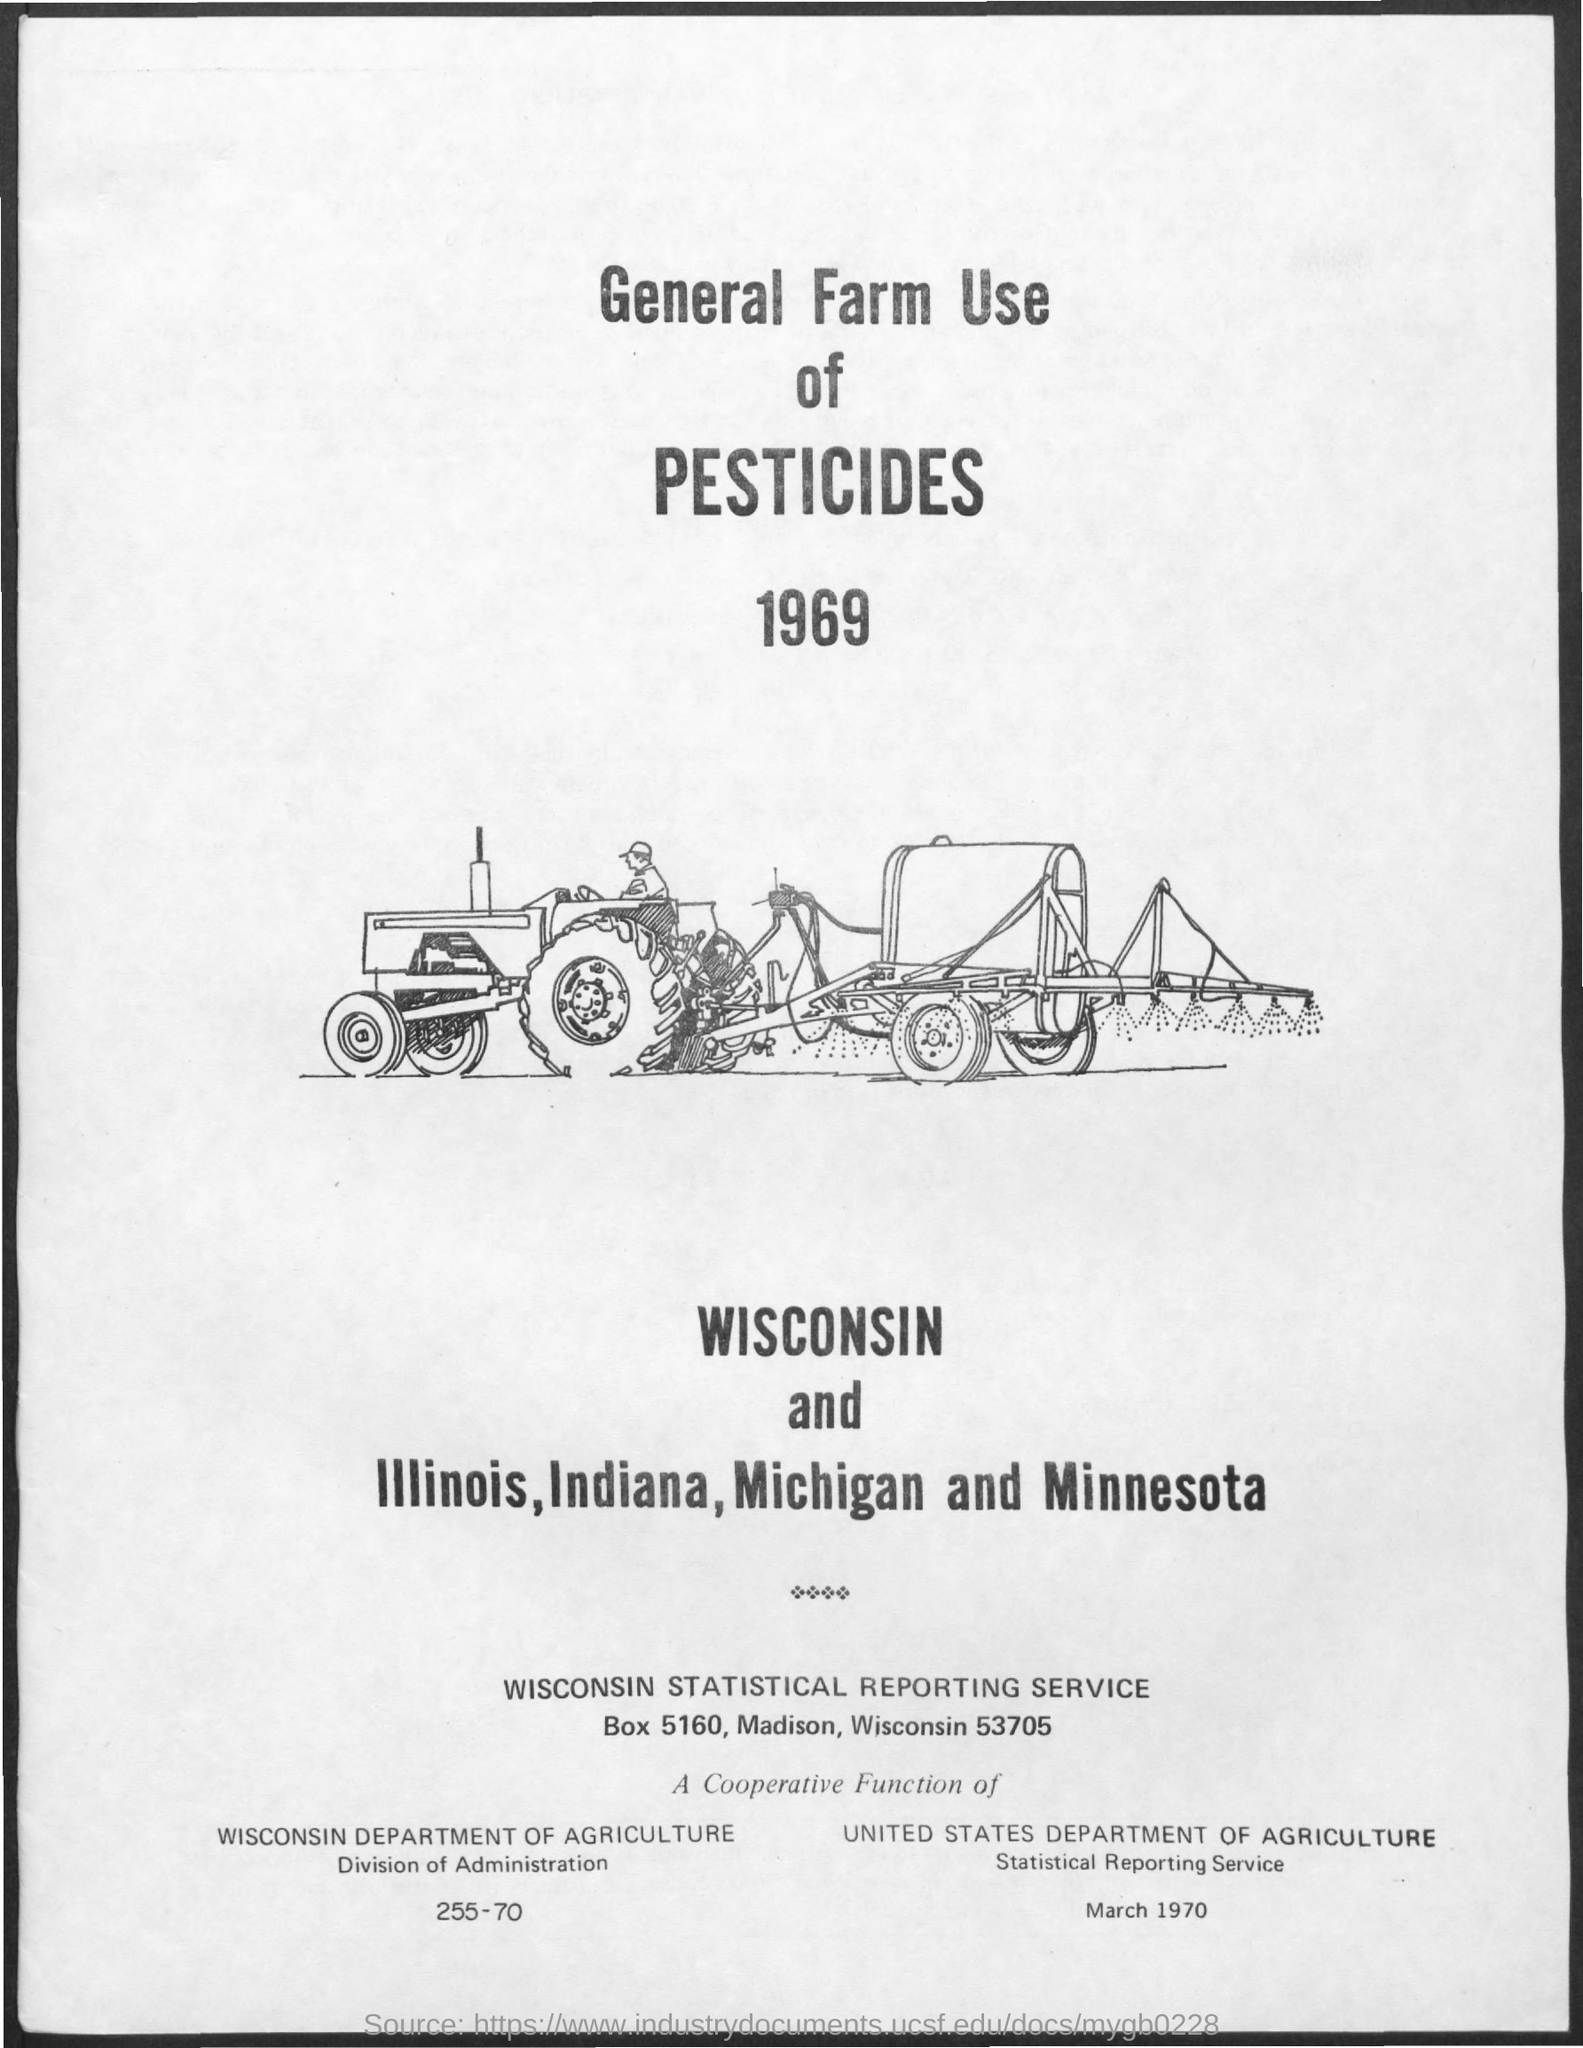Specify some key components in this picture. The document is titled "General farm use of pesticides in 1969. The address for the Wisconsin statistical reporting service is box 5160 in Madison, Wisconsin 53705. 